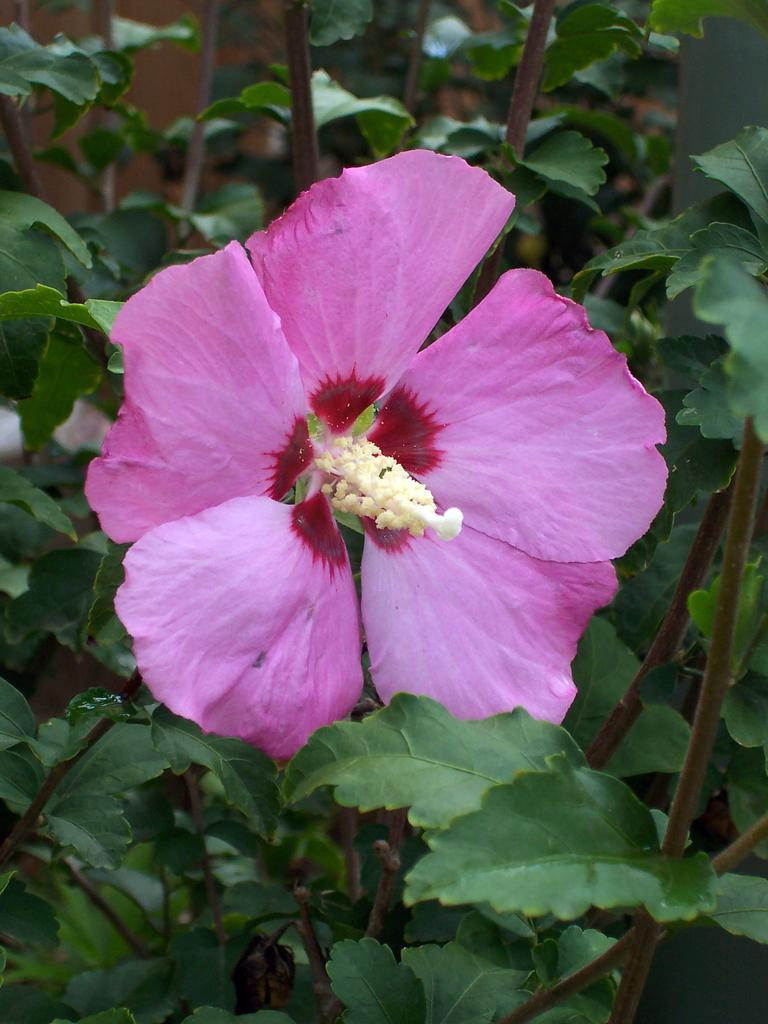What is the main subject in the middle of the image? There is a flower in the middle of the image. What else can be seen in the image besides the flower? There are plants in the image. What type of leather is used to make the square sock in the image? There is no leather, square, or sock present in the image; it features a flower and plants. 